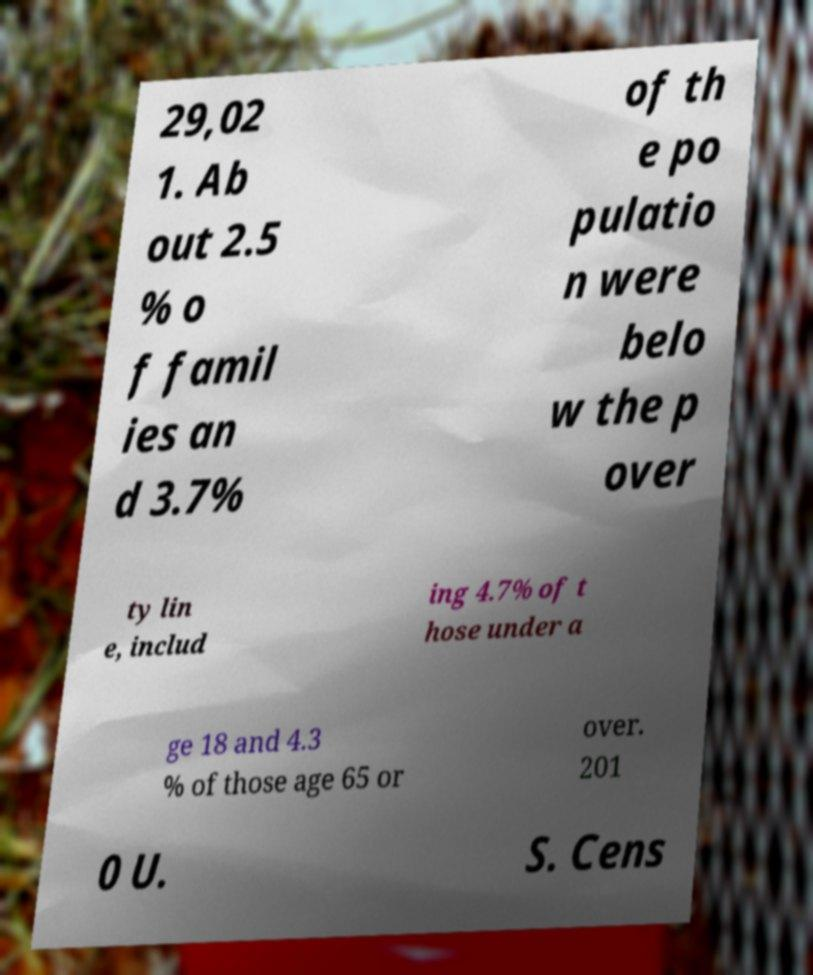Could you extract and type out the text from this image? 29,02 1. Ab out 2.5 % o f famil ies an d 3.7% of th e po pulatio n were belo w the p over ty lin e, includ ing 4.7% of t hose under a ge 18 and 4.3 % of those age 65 or over. 201 0 U. S. Cens 